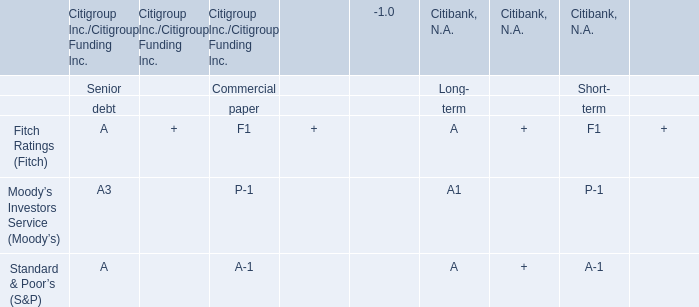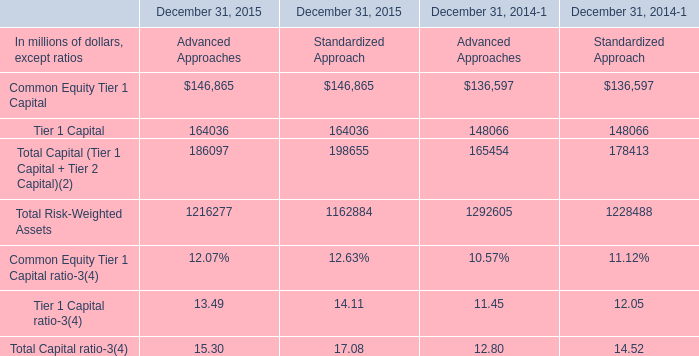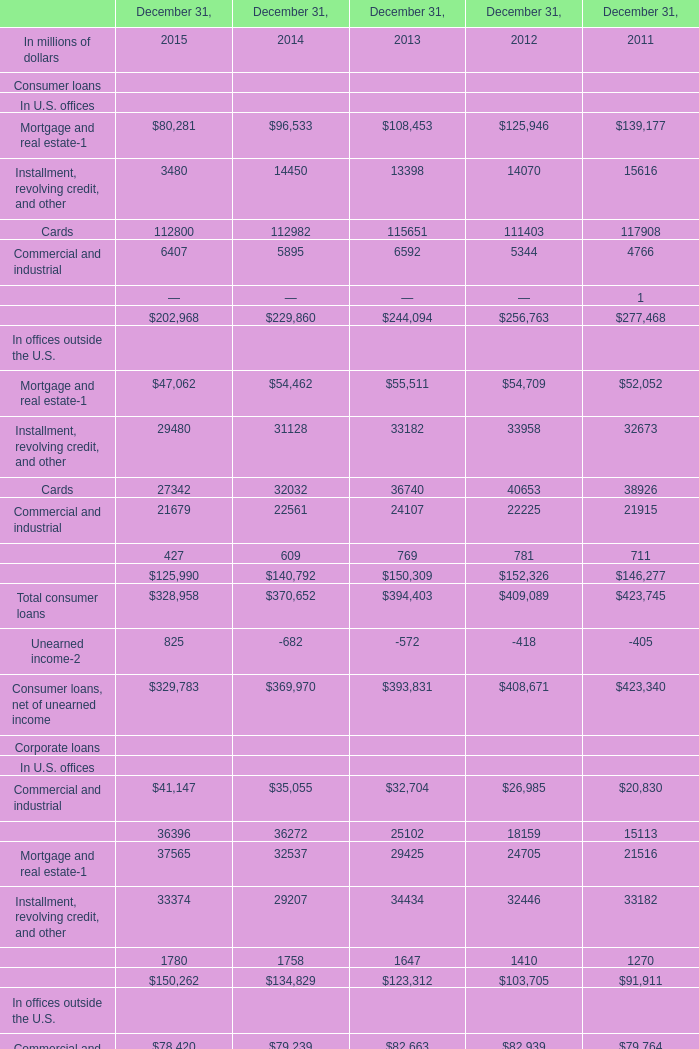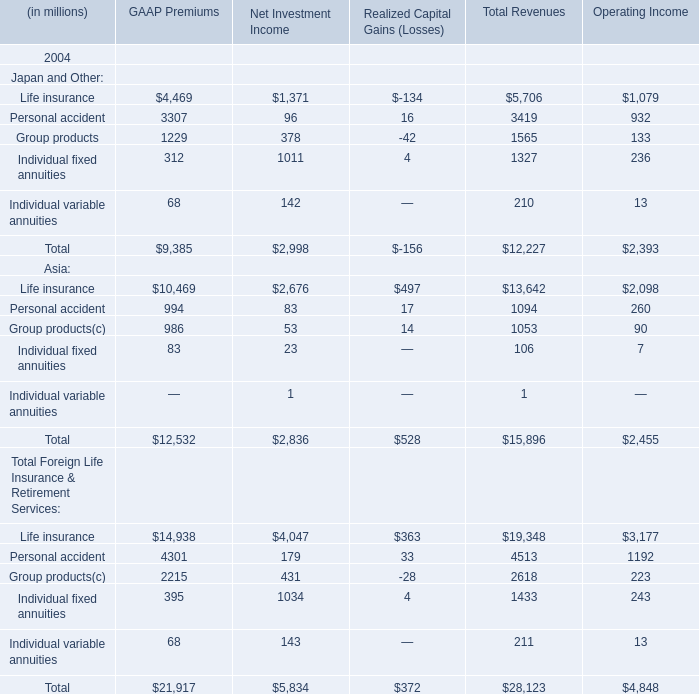What is the amount of the Operating Income of the subterm with the highest Operating Income in terms of Japan and Other in 2004? (in dollars in millions) 
Answer: 1079. 